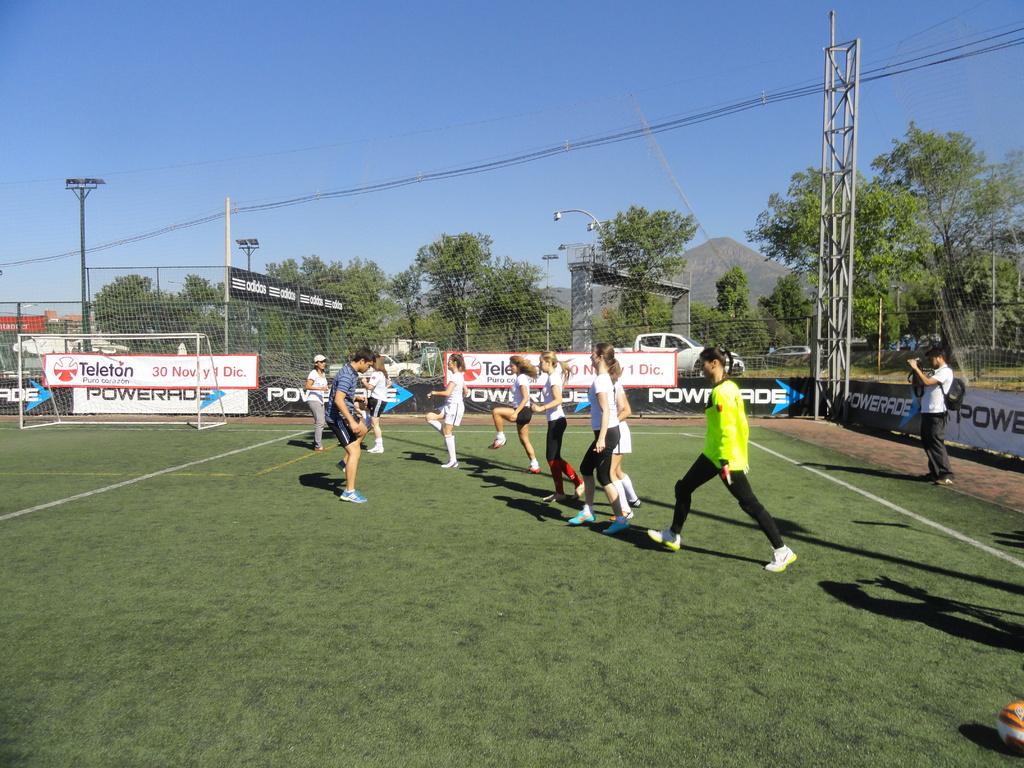Is powerade a sponsor?
Keep it short and to the point. Yes. What television is sponsor there?
Keep it short and to the point. Teleton. 